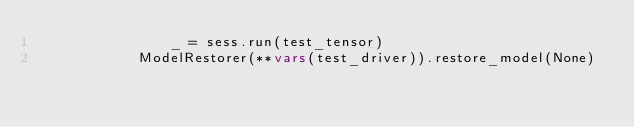<code> <loc_0><loc_0><loc_500><loc_500><_Python_>                _ = sess.run(test_tensor)
            ModelRestorer(**vars(test_driver)).restore_model(None)</code> 